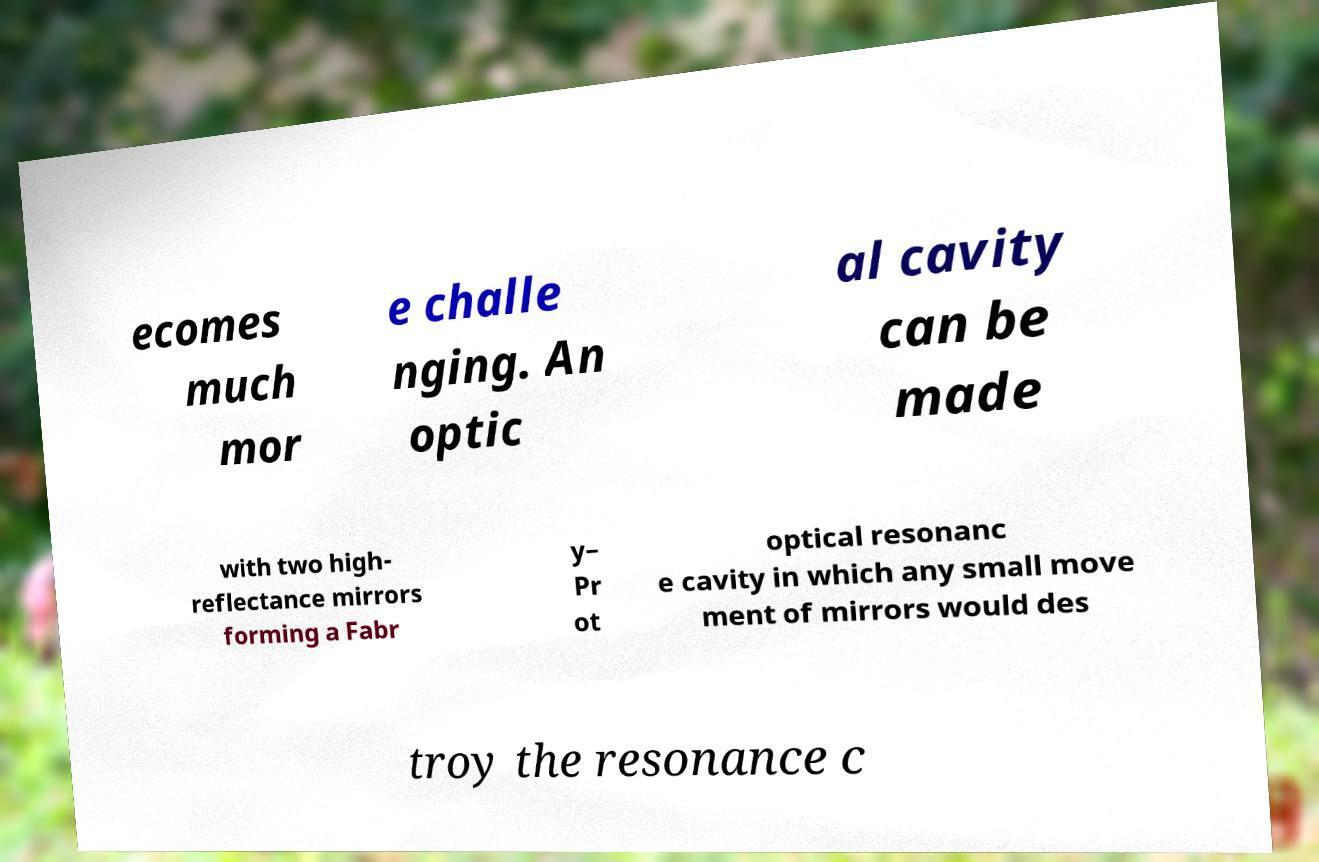Could you assist in decoding the text presented in this image and type it out clearly? ecomes much mor e challe nging. An optic al cavity can be made with two high- reflectance mirrors forming a Fabr y– Pr ot optical resonanc e cavity in which any small move ment of mirrors would des troy the resonance c 